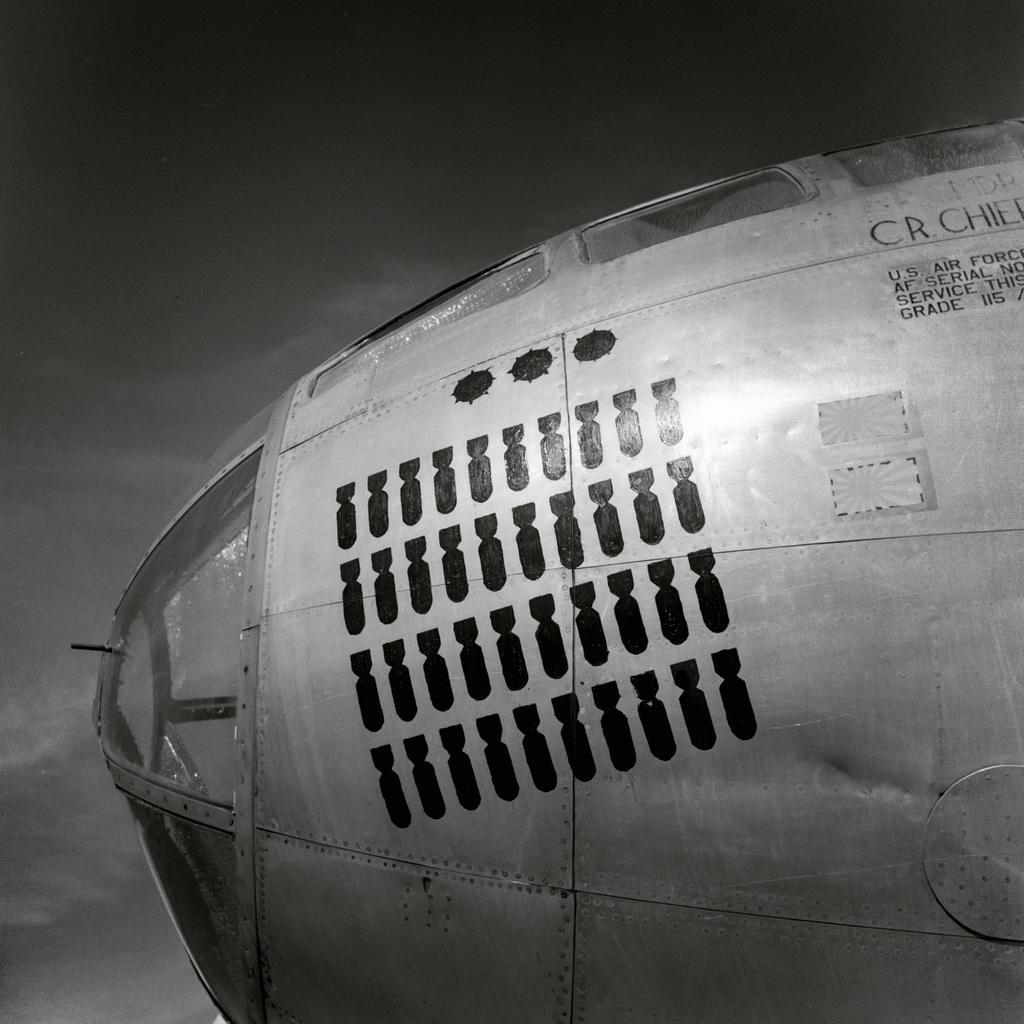Could you give a brief overview of what you see in this image? In this image I can see an object. Here I can see something written on the object. In the background I can see the sky. This picture is black and white in color. 